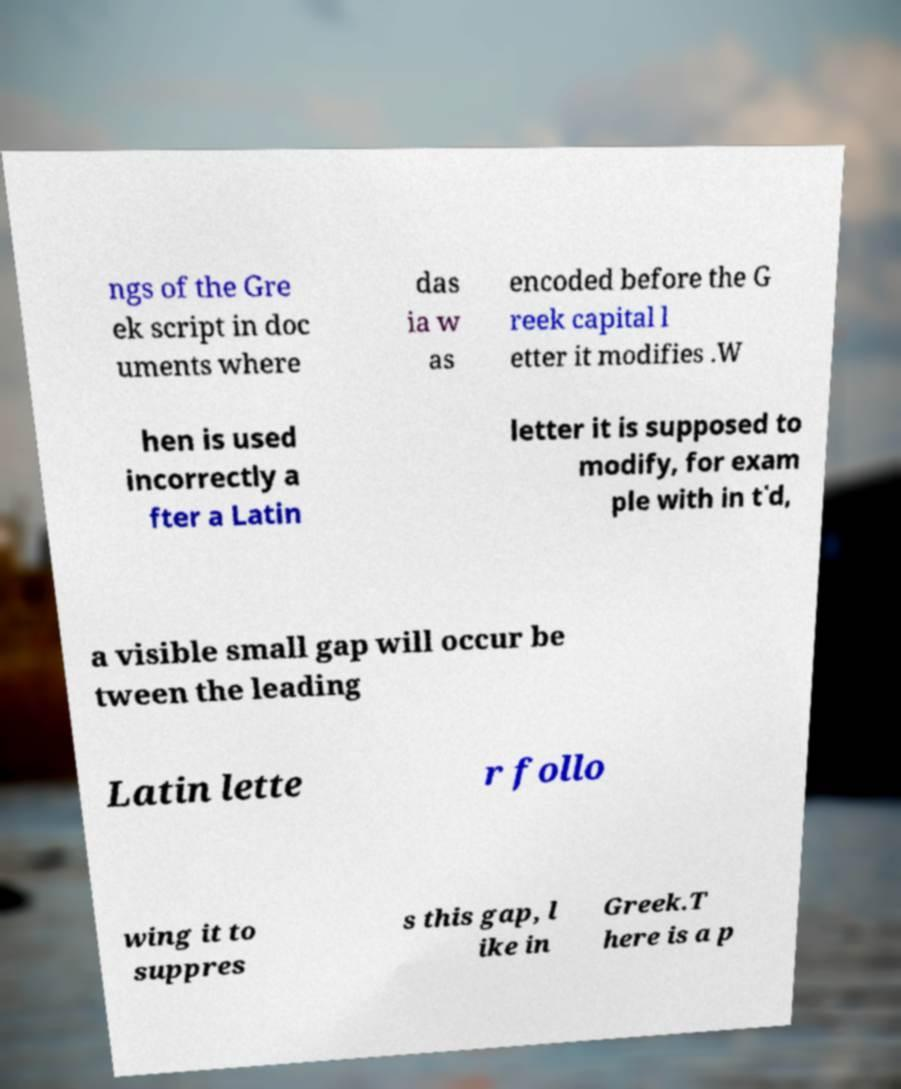Please identify and transcribe the text found in this image. ngs of the Gre ek script in doc uments where das ia w as encoded before the G reek capital l etter it modifies .W hen is used incorrectly a fter a Latin letter it is supposed to modify, for exam ple with in t῾d, a visible small gap will occur be tween the leading Latin lette r follo wing it to suppres s this gap, l ike in Greek.T here is a p 